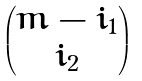Convert formula to latex. <formula><loc_0><loc_0><loc_500><loc_500>\begin{pmatrix} m - i _ { 1 } \\ i _ { 2 } \end{pmatrix}</formula> 